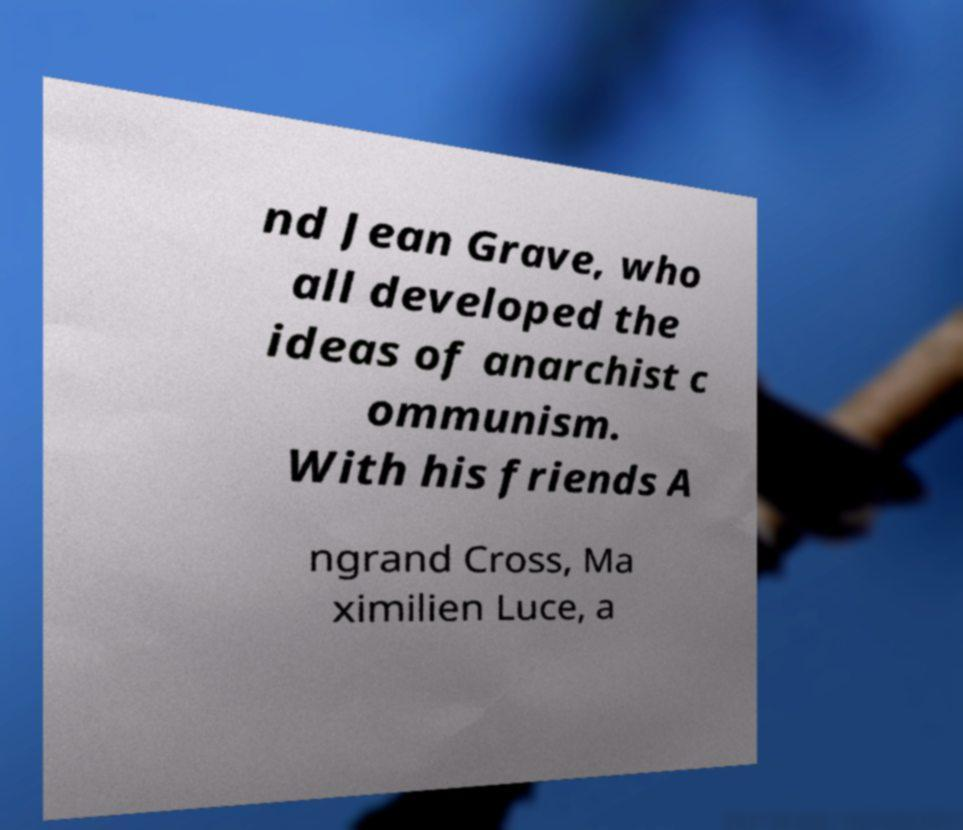Can you read and provide the text displayed in the image?This photo seems to have some interesting text. Can you extract and type it out for me? nd Jean Grave, who all developed the ideas of anarchist c ommunism. With his friends A ngrand Cross, Ma ximilien Luce, a 